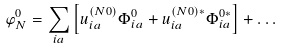Convert formula to latex. <formula><loc_0><loc_0><loc_500><loc_500>\varphi _ { N } ^ { 0 } = \sum _ { i a } \left [ u _ { i a } ^ { ( N 0 ) } \Phi _ { i a } ^ { 0 } + u _ { i a } ^ { ( N 0 ) * } \Phi _ { i a } ^ { 0 * } \right ] + \dots</formula> 